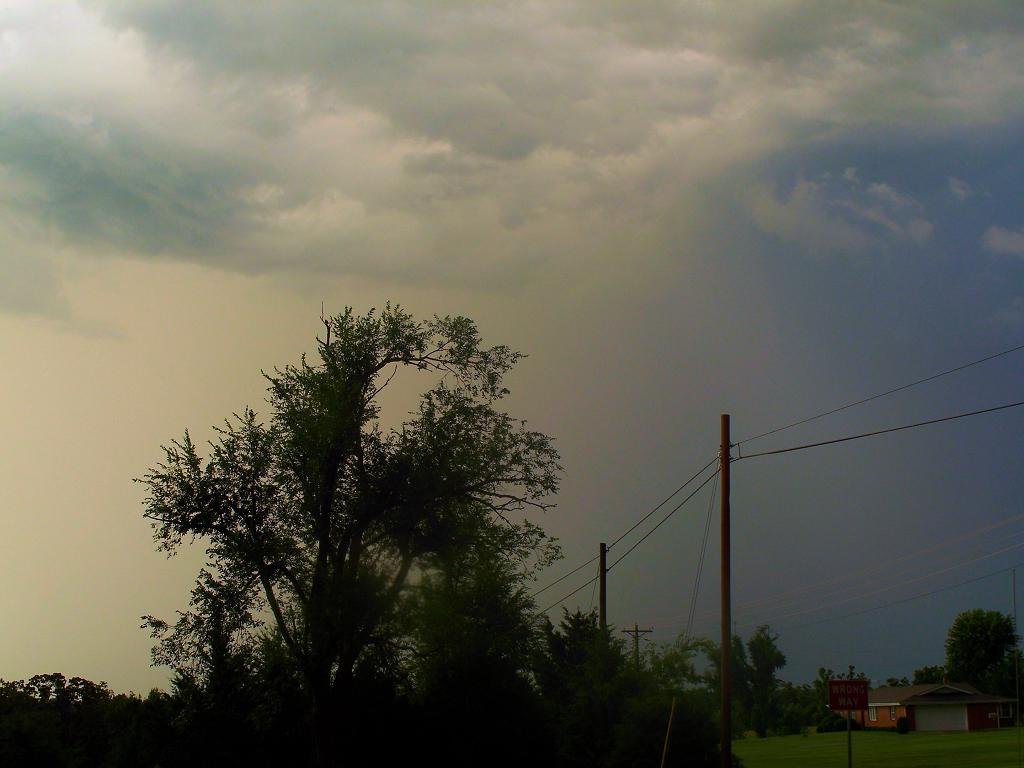What type of vegetation can be seen in the image? There are trees in the image. What infrastructure elements are present in the image? There are current poles with wires and a board with a pole in the image. Where is the house located in the image? The house is in the bottom right side of the image. What can be seen in the background of the image? The sky is visible in the background of the image. Can you tell me how many snails are crawling on the current poles in the image? There are no snails present on the current poles in the image. What type of unit is being used to measure the height of the trees in the image? There is no unit mentioned or implied in the image for measuring the height of the trees. 